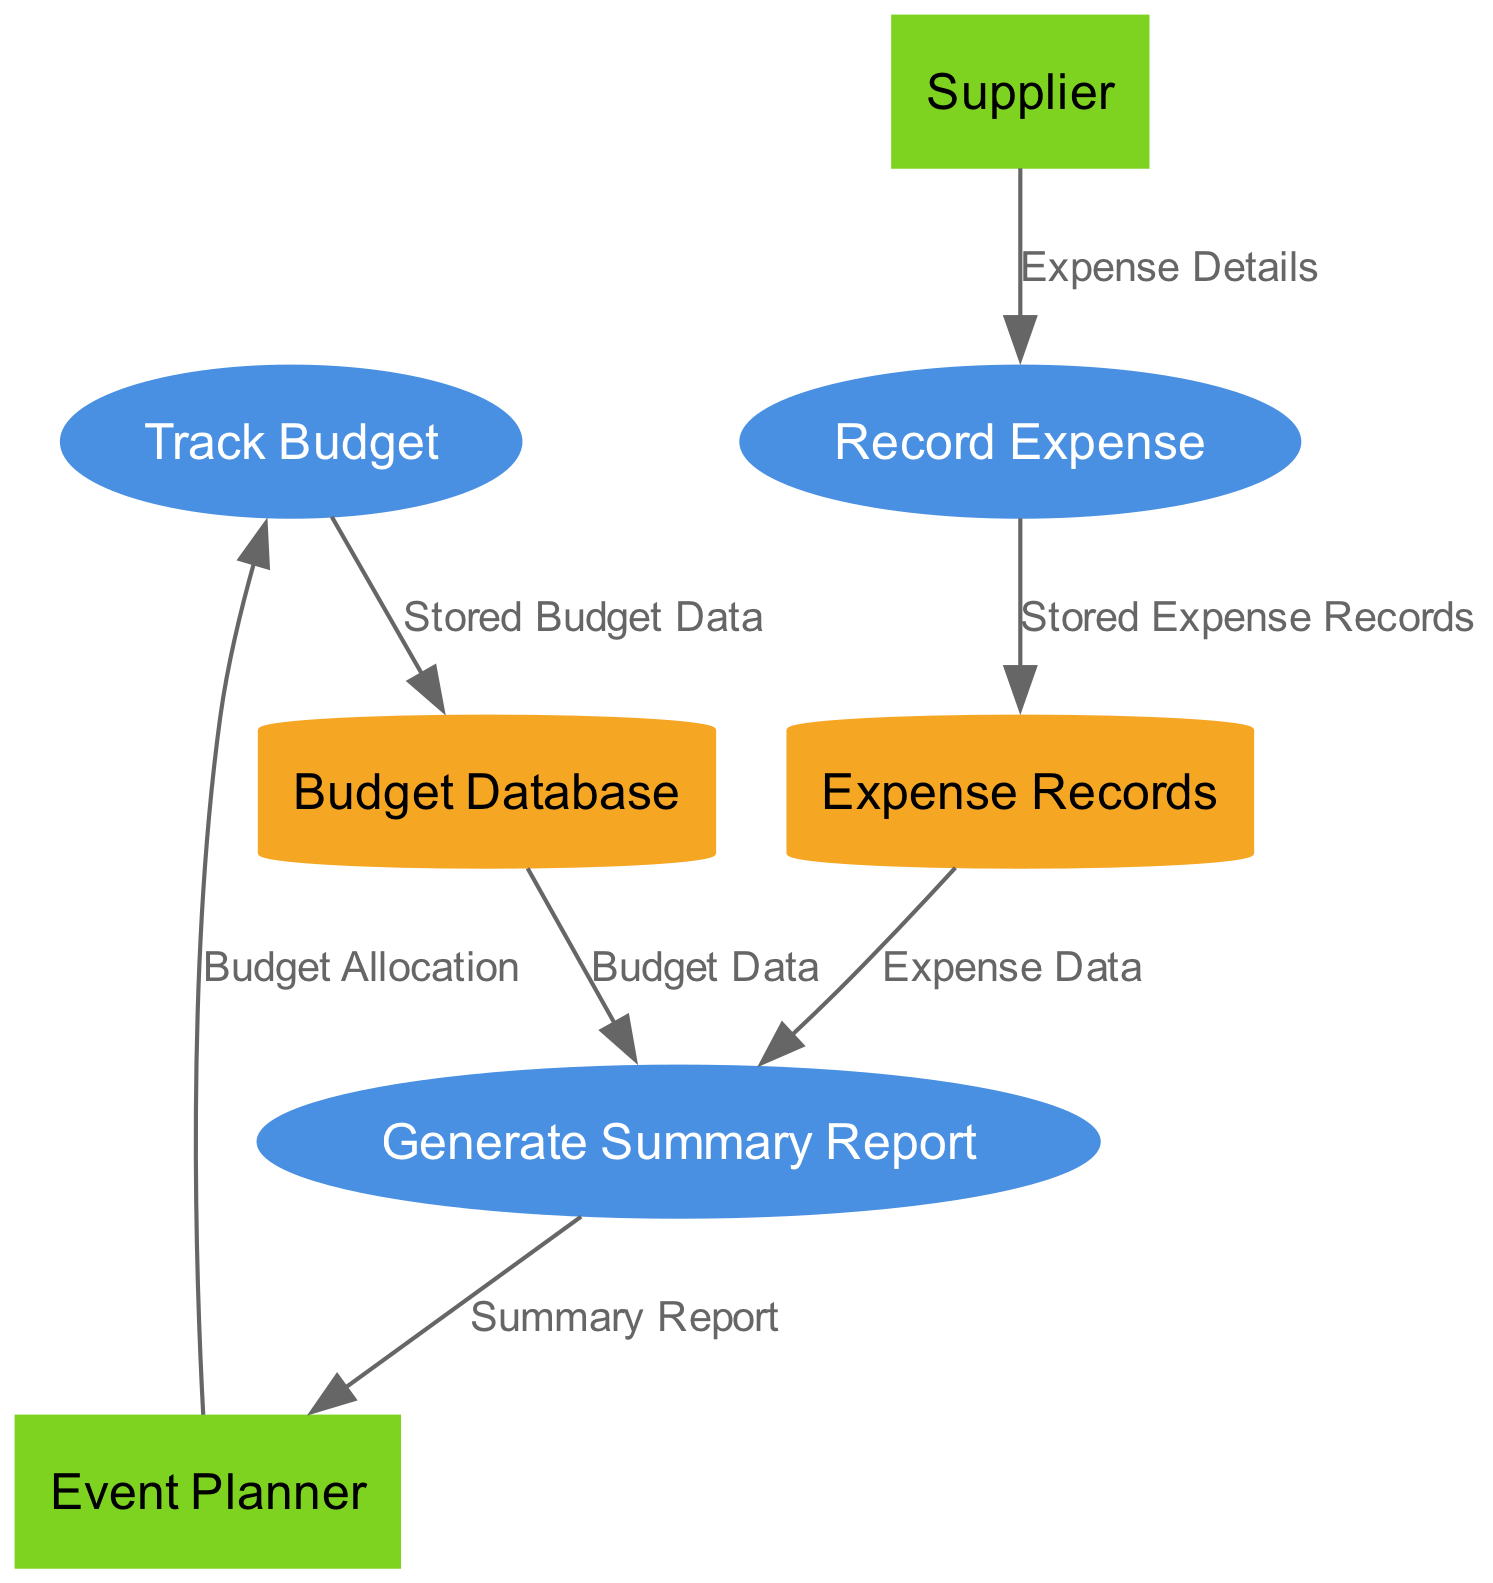What are the processes in the diagram? The diagram includes three processes: "Track Budget", "Record Expense", and "Generate Summary Report." Each of these processes is depicted with an oval shape in the diagram.
Answer: Track Budget, Record Expense, Generate Summary Report Who is the external entity that allocates the budget? The external entity responsible for budget allocation is the "Event Planner." This is shown as a rectangle labeled with the entity's name.
Answer: Event Planner How many data stores are in the diagram? There are two data stores in the diagram: "Budget Database" and "Expense Records." Each is represented by a cylinder shape.
Answer: 2 What data flows from the "Budget Database" to the "Generate Summary Report"? The data flowing from the "Budget Database" to the "Generate Summary Report" is labeled "Budget Data." This indicates that this piece of information is used in generating the report.
Answer: Budget Data Which external entity provides the "Expense Details"? The external entity that provides the "Expense Details" is the "Supplier." This relationship is depicted as a flow directed from the "Supplier" to the "Record Expense" process.
Answer: Supplier What process records expenses? The process that records expenses is "Record Expense." This is clearly labeled in the diagram with an elliptical shape.
Answer: Record Expense What is the output of the "Generate Summary Report" process? The output of the "Generate Summary Report" process is the "Summary Report," which is sent back to the "Event Planner." This is depicted by the flow leading from the report process back to the planner.
Answer: Summary Report What does the "Event Planner" send as input to the "Track Budget" process? The "Event Planner" sends "Budget Allocation" as input to the "Track Budget" process. This is indicated by the flow originating from the planner and pointing to the budgeting process.
Answer: Budget Allocation Which data store receives stored expense records? The data store that receives stored expense records is "Expense Records." This store collects the data produced from the "Record Expense" process.
Answer: Expense Records 